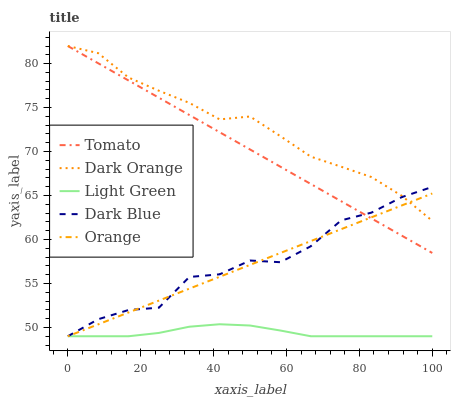Does Light Green have the minimum area under the curve?
Answer yes or no. Yes. Does Dark Orange have the maximum area under the curve?
Answer yes or no. Yes. Does Orange have the minimum area under the curve?
Answer yes or no. No. Does Orange have the maximum area under the curve?
Answer yes or no. No. Is Orange the smoothest?
Answer yes or no. Yes. Is Dark Blue the roughest?
Answer yes or no. Yes. Is Dark Orange the smoothest?
Answer yes or no. No. Is Dark Orange the roughest?
Answer yes or no. No. Does Dark Orange have the lowest value?
Answer yes or no. No. Does Dark Orange have the highest value?
Answer yes or no. Yes. Does Orange have the highest value?
Answer yes or no. No. Is Light Green less than Tomato?
Answer yes or no. Yes. Is Dark Orange greater than Light Green?
Answer yes or no. Yes. Does Light Green intersect Dark Blue?
Answer yes or no. Yes. Is Light Green less than Dark Blue?
Answer yes or no. No. Is Light Green greater than Dark Blue?
Answer yes or no. No. Does Light Green intersect Tomato?
Answer yes or no. No. 